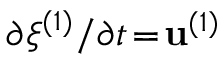Convert formula to latex. <formula><loc_0><loc_0><loc_500><loc_500>\partial \xi ^ { ( 1 ) } / \partial t \, = \, u ^ { ( 1 ) }</formula> 